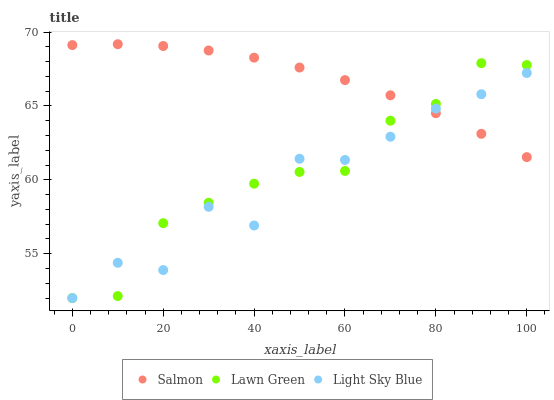Does Light Sky Blue have the minimum area under the curve?
Answer yes or no. Yes. Does Salmon have the maximum area under the curve?
Answer yes or no. Yes. Does Salmon have the minimum area under the curve?
Answer yes or no. No. Does Light Sky Blue have the maximum area under the curve?
Answer yes or no. No. Is Salmon the smoothest?
Answer yes or no. Yes. Is Light Sky Blue the roughest?
Answer yes or no. Yes. Is Light Sky Blue the smoothest?
Answer yes or no. No. Is Salmon the roughest?
Answer yes or no. No. Does Lawn Green have the lowest value?
Answer yes or no. Yes. Does Salmon have the lowest value?
Answer yes or no. No. Does Salmon have the highest value?
Answer yes or no. Yes. Does Light Sky Blue have the highest value?
Answer yes or no. No. Does Salmon intersect Light Sky Blue?
Answer yes or no. Yes. Is Salmon less than Light Sky Blue?
Answer yes or no. No. Is Salmon greater than Light Sky Blue?
Answer yes or no. No. 